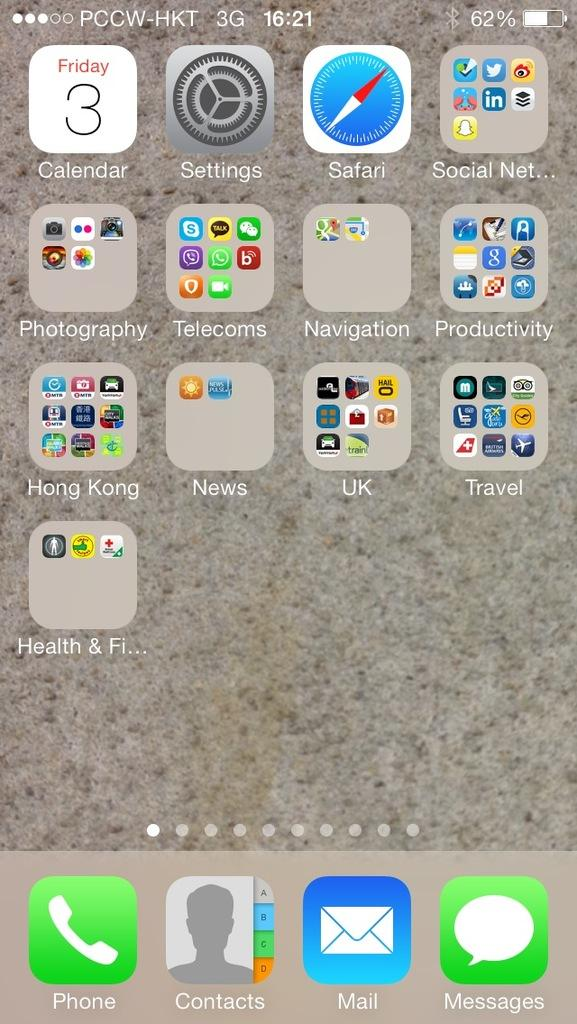<image>
Write a terse but informative summary of the picture. A phone screen shows app categories that include Hong Kong, News, and Navigation. 